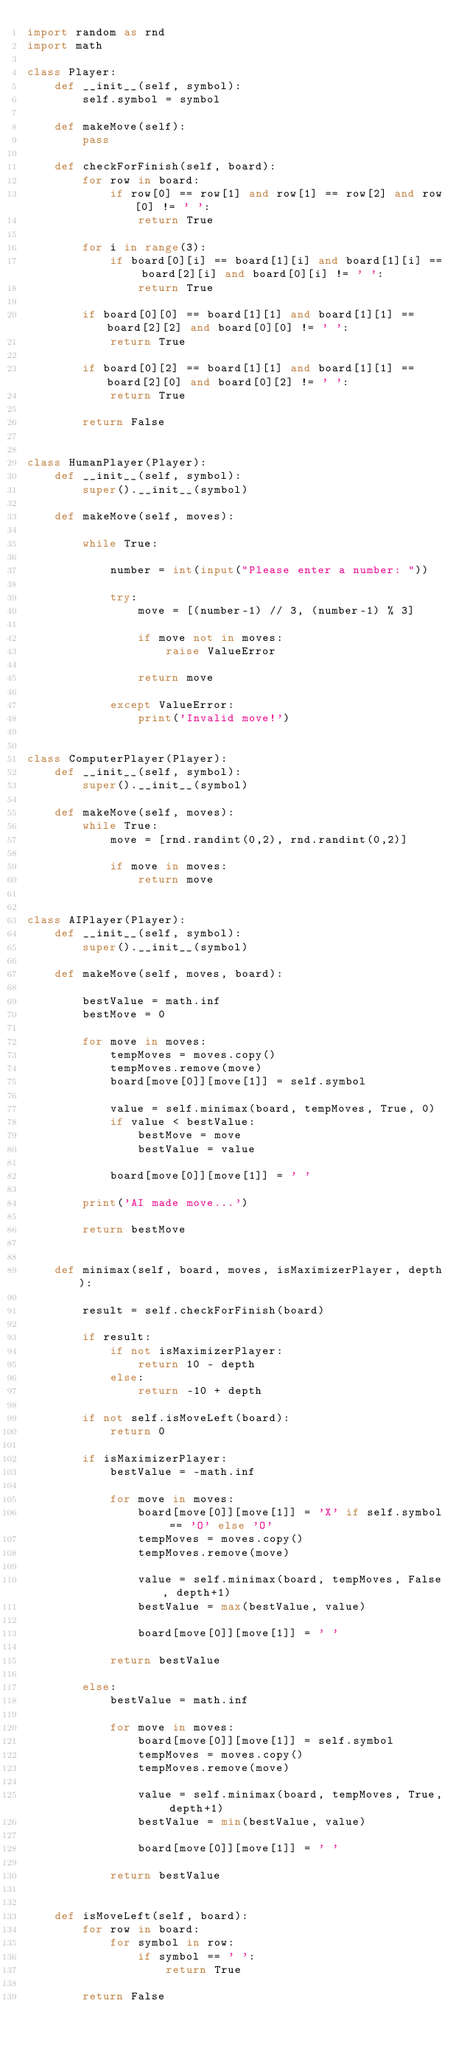Convert code to text. <code><loc_0><loc_0><loc_500><loc_500><_Python_>import random as rnd
import math

class Player:
    def __init__(self, symbol):
        self.symbol = symbol

    def makeMove(self):
        pass

    def checkForFinish(self, board):
        for row in board:
            if row[0] == row[1] and row[1] == row[2] and row[0] != ' ':
                return True
        
        for i in range(3):
            if board[0][i] == board[1][i] and board[1][i] == board[2][i] and board[0][i] != ' ':
                return True
        
        if board[0][0] == board[1][1] and board[1][1] == board[2][2] and board[0][0] != ' ':
            return True

        if board[0][2] == board[1][1] and board[1][1] == board[2][0] and board[0][2] != ' ':
            return True

        return False 


class HumanPlayer(Player):
    def __init__(self, symbol):
        super().__init__(symbol)
    
    def makeMove(self, moves):

        while True:

            number = int(input("Please enter a number: "))
            
            try:
                move = [(number-1) // 3, (number-1) % 3]

                if move not in moves:
                    raise ValueError
                
                return move

            except ValueError:
                print('Invalid move!')
        

class ComputerPlayer(Player):
    def __init__(self, symbol):
        super().__init__(symbol)
    
    def makeMove(self, moves):
        while True:
            move = [rnd.randint(0,2), rnd.randint(0,2)]

            if move in moves:
                return move


class AIPlayer(Player):
    def __init__(self, symbol):
        super().__init__(symbol)
    
    def makeMove(self, moves, board):
        
        bestValue = math.inf
        bestMove = 0

        for move in moves:
            tempMoves = moves.copy()
            tempMoves.remove(move)
            board[move[0]][move[1]] = self.symbol

            value = self.minimax(board, tempMoves, True, 0)
            if value < bestValue:
                bestMove = move
                bestValue = value
            
            board[move[0]][move[1]] = ' '
        
        print('AI made move...')
        
        return bestMove


    def minimax(self, board, moves, isMaximizerPlayer, depth):

        result = self.checkForFinish(board)

        if result:
            if not isMaximizerPlayer:
                return 10 - depth
            else:
                return -10 + depth
        
        if not self.isMoveLeft(board):
            return 0

        if isMaximizerPlayer:
            bestValue = -math.inf

            for move in moves:
                board[move[0]][move[1]] = 'X' if self.symbol == 'O' else 'O'
                tempMoves = moves.copy()
                tempMoves.remove(move)

                value = self.minimax(board, tempMoves, False, depth+1)
                bestValue = max(bestValue, value)

                board[move[0]][move[1]] = ' '
            
            return bestValue

        else:
            bestValue = math.inf

            for move in moves:
                board[move[0]][move[1]] = self.symbol
                tempMoves = moves.copy()
                tempMoves.remove(move)

                value = self.minimax(board, tempMoves, True, depth+1)
                bestValue = min(bestValue, value)

                board[move[0]][move[1]] = ' '
            
            return bestValue


    def isMoveLeft(self, board):
        for row in board:
            for symbol in row:
                if symbol == ' ':
                    return True

        return False</code> 